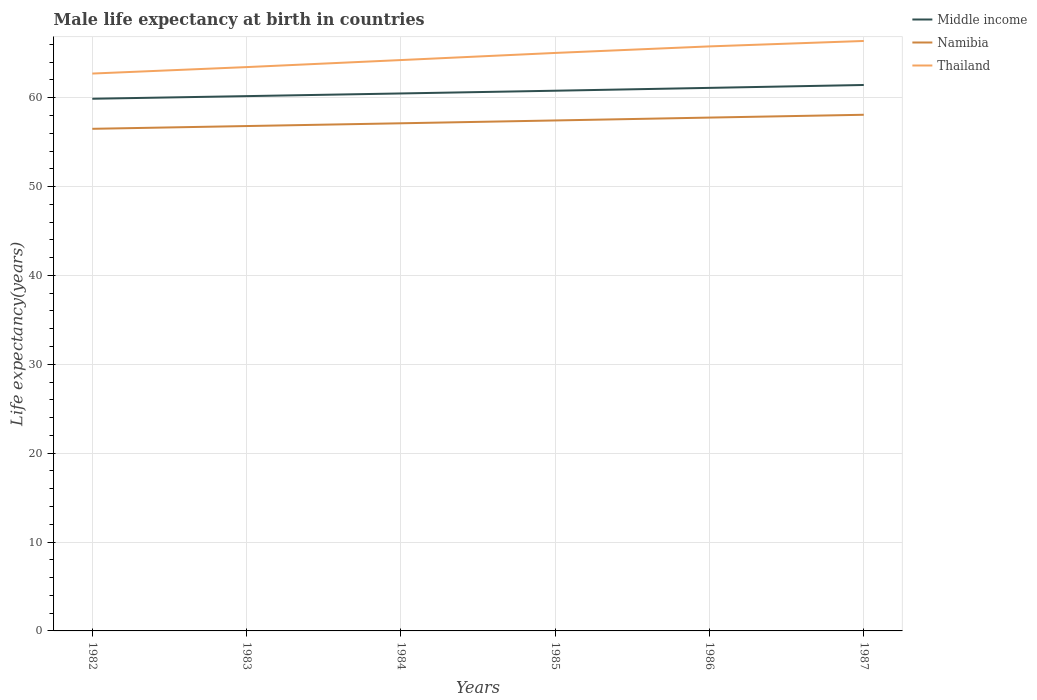Does the line corresponding to Namibia intersect with the line corresponding to Middle income?
Your answer should be compact. No. Across all years, what is the maximum male life expectancy at birth in Namibia?
Provide a succinct answer. 56.5. In which year was the male life expectancy at birth in Thailand maximum?
Offer a terse response. 1982. What is the total male life expectancy at birth in Namibia in the graph?
Offer a terse response. -0.94. What is the difference between the highest and the second highest male life expectancy at birth in Middle income?
Your response must be concise. 1.55. What is the difference between the highest and the lowest male life expectancy at birth in Middle income?
Ensure brevity in your answer.  3. Is the male life expectancy at birth in Middle income strictly greater than the male life expectancy at birth in Namibia over the years?
Provide a short and direct response. No. What is the difference between two consecutive major ticks on the Y-axis?
Ensure brevity in your answer.  10. Are the values on the major ticks of Y-axis written in scientific E-notation?
Provide a short and direct response. No. Does the graph contain grids?
Provide a succinct answer. Yes. Where does the legend appear in the graph?
Offer a very short reply. Top right. What is the title of the graph?
Your answer should be very brief. Male life expectancy at birth in countries. What is the label or title of the X-axis?
Offer a very short reply. Years. What is the label or title of the Y-axis?
Your answer should be compact. Life expectancy(years). What is the Life expectancy(years) of Middle income in 1982?
Make the answer very short. 59.88. What is the Life expectancy(years) in Namibia in 1982?
Your answer should be very brief. 56.5. What is the Life expectancy(years) in Thailand in 1982?
Your response must be concise. 62.72. What is the Life expectancy(years) in Middle income in 1983?
Offer a terse response. 60.18. What is the Life expectancy(years) of Namibia in 1983?
Keep it short and to the point. 56.81. What is the Life expectancy(years) of Thailand in 1983?
Offer a very short reply. 63.45. What is the Life expectancy(years) of Middle income in 1984?
Offer a terse response. 60.48. What is the Life expectancy(years) of Namibia in 1984?
Keep it short and to the point. 57.12. What is the Life expectancy(years) of Thailand in 1984?
Offer a terse response. 64.24. What is the Life expectancy(years) of Middle income in 1985?
Your answer should be very brief. 60.79. What is the Life expectancy(years) in Namibia in 1985?
Give a very brief answer. 57.44. What is the Life expectancy(years) in Thailand in 1985?
Offer a very short reply. 65.04. What is the Life expectancy(years) in Middle income in 1986?
Ensure brevity in your answer.  61.11. What is the Life expectancy(years) in Namibia in 1986?
Your answer should be very brief. 57.77. What is the Life expectancy(years) in Thailand in 1986?
Your answer should be very brief. 65.78. What is the Life expectancy(years) in Middle income in 1987?
Provide a succinct answer. 61.43. What is the Life expectancy(years) of Namibia in 1987?
Provide a short and direct response. 58.08. What is the Life expectancy(years) in Thailand in 1987?
Keep it short and to the point. 66.39. Across all years, what is the maximum Life expectancy(years) of Middle income?
Keep it short and to the point. 61.43. Across all years, what is the maximum Life expectancy(years) of Namibia?
Provide a short and direct response. 58.08. Across all years, what is the maximum Life expectancy(years) of Thailand?
Ensure brevity in your answer.  66.39. Across all years, what is the minimum Life expectancy(years) in Middle income?
Give a very brief answer. 59.88. Across all years, what is the minimum Life expectancy(years) of Namibia?
Keep it short and to the point. 56.5. Across all years, what is the minimum Life expectancy(years) in Thailand?
Your answer should be compact. 62.72. What is the total Life expectancy(years) of Middle income in the graph?
Offer a very short reply. 363.87. What is the total Life expectancy(years) of Namibia in the graph?
Your response must be concise. 343.73. What is the total Life expectancy(years) of Thailand in the graph?
Provide a succinct answer. 387.6. What is the difference between the Life expectancy(years) of Middle income in 1982 and that in 1983?
Your answer should be compact. -0.3. What is the difference between the Life expectancy(years) of Namibia in 1982 and that in 1983?
Ensure brevity in your answer.  -0.31. What is the difference between the Life expectancy(years) of Thailand in 1982 and that in 1983?
Make the answer very short. -0.73. What is the difference between the Life expectancy(years) of Middle income in 1982 and that in 1984?
Offer a very short reply. -0.6. What is the difference between the Life expectancy(years) in Namibia in 1982 and that in 1984?
Your response must be concise. -0.62. What is the difference between the Life expectancy(years) of Thailand in 1982 and that in 1984?
Provide a succinct answer. -1.52. What is the difference between the Life expectancy(years) of Middle income in 1982 and that in 1985?
Provide a succinct answer. -0.9. What is the difference between the Life expectancy(years) in Namibia in 1982 and that in 1985?
Offer a very short reply. -0.94. What is the difference between the Life expectancy(years) of Thailand in 1982 and that in 1985?
Offer a terse response. -2.32. What is the difference between the Life expectancy(years) of Middle income in 1982 and that in 1986?
Keep it short and to the point. -1.22. What is the difference between the Life expectancy(years) of Namibia in 1982 and that in 1986?
Keep it short and to the point. -1.26. What is the difference between the Life expectancy(years) in Thailand in 1982 and that in 1986?
Keep it short and to the point. -3.06. What is the difference between the Life expectancy(years) in Middle income in 1982 and that in 1987?
Your answer should be very brief. -1.55. What is the difference between the Life expectancy(years) in Namibia in 1982 and that in 1987?
Keep it short and to the point. -1.58. What is the difference between the Life expectancy(years) in Thailand in 1982 and that in 1987?
Your answer should be compact. -3.67. What is the difference between the Life expectancy(years) of Middle income in 1983 and that in 1984?
Ensure brevity in your answer.  -0.3. What is the difference between the Life expectancy(years) in Namibia in 1983 and that in 1984?
Your answer should be very brief. -0.31. What is the difference between the Life expectancy(years) in Thailand in 1983 and that in 1984?
Your answer should be very brief. -0.79. What is the difference between the Life expectancy(years) in Middle income in 1983 and that in 1985?
Your answer should be very brief. -0.61. What is the difference between the Life expectancy(years) of Namibia in 1983 and that in 1985?
Ensure brevity in your answer.  -0.63. What is the difference between the Life expectancy(years) of Thailand in 1983 and that in 1985?
Keep it short and to the point. -1.59. What is the difference between the Life expectancy(years) of Middle income in 1983 and that in 1986?
Provide a short and direct response. -0.93. What is the difference between the Life expectancy(years) of Namibia in 1983 and that in 1986?
Your answer should be very brief. -0.95. What is the difference between the Life expectancy(years) in Thailand in 1983 and that in 1986?
Offer a terse response. -2.33. What is the difference between the Life expectancy(years) in Middle income in 1983 and that in 1987?
Provide a short and direct response. -1.25. What is the difference between the Life expectancy(years) of Namibia in 1983 and that in 1987?
Provide a succinct answer. -1.27. What is the difference between the Life expectancy(years) of Thailand in 1983 and that in 1987?
Your answer should be compact. -2.94. What is the difference between the Life expectancy(years) in Middle income in 1984 and that in 1985?
Your answer should be compact. -0.31. What is the difference between the Life expectancy(years) in Namibia in 1984 and that in 1985?
Your response must be concise. -0.32. What is the difference between the Life expectancy(years) of Thailand in 1984 and that in 1985?
Provide a succinct answer. -0.8. What is the difference between the Life expectancy(years) of Middle income in 1984 and that in 1986?
Provide a succinct answer. -0.63. What is the difference between the Life expectancy(years) in Namibia in 1984 and that in 1986?
Give a very brief answer. -0.64. What is the difference between the Life expectancy(years) of Thailand in 1984 and that in 1986?
Offer a very short reply. -1.54. What is the difference between the Life expectancy(years) in Middle income in 1984 and that in 1987?
Make the answer very short. -0.95. What is the difference between the Life expectancy(years) of Namibia in 1984 and that in 1987?
Your answer should be compact. -0.96. What is the difference between the Life expectancy(years) of Thailand in 1984 and that in 1987?
Your answer should be compact. -2.15. What is the difference between the Life expectancy(years) of Middle income in 1985 and that in 1986?
Offer a terse response. -0.32. What is the difference between the Life expectancy(years) of Namibia in 1985 and that in 1986?
Ensure brevity in your answer.  -0.32. What is the difference between the Life expectancy(years) in Thailand in 1985 and that in 1986?
Ensure brevity in your answer.  -0.74. What is the difference between the Life expectancy(years) in Middle income in 1985 and that in 1987?
Keep it short and to the point. -0.64. What is the difference between the Life expectancy(years) in Namibia in 1985 and that in 1987?
Ensure brevity in your answer.  -0.64. What is the difference between the Life expectancy(years) in Thailand in 1985 and that in 1987?
Offer a terse response. -1.35. What is the difference between the Life expectancy(years) in Middle income in 1986 and that in 1987?
Offer a terse response. -0.33. What is the difference between the Life expectancy(years) of Namibia in 1986 and that in 1987?
Your answer should be very brief. -0.32. What is the difference between the Life expectancy(years) in Thailand in 1986 and that in 1987?
Offer a terse response. -0.61. What is the difference between the Life expectancy(years) of Middle income in 1982 and the Life expectancy(years) of Namibia in 1983?
Offer a terse response. 3.07. What is the difference between the Life expectancy(years) in Middle income in 1982 and the Life expectancy(years) in Thailand in 1983?
Offer a very short reply. -3.56. What is the difference between the Life expectancy(years) in Namibia in 1982 and the Life expectancy(years) in Thailand in 1983?
Your response must be concise. -6.95. What is the difference between the Life expectancy(years) of Middle income in 1982 and the Life expectancy(years) of Namibia in 1984?
Provide a succinct answer. 2.76. What is the difference between the Life expectancy(years) in Middle income in 1982 and the Life expectancy(years) in Thailand in 1984?
Provide a succinct answer. -4.35. What is the difference between the Life expectancy(years) in Namibia in 1982 and the Life expectancy(years) in Thailand in 1984?
Provide a short and direct response. -7.74. What is the difference between the Life expectancy(years) in Middle income in 1982 and the Life expectancy(years) in Namibia in 1985?
Give a very brief answer. 2.44. What is the difference between the Life expectancy(years) in Middle income in 1982 and the Life expectancy(years) in Thailand in 1985?
Give a very brief answer. -5.15. What is the difference between the Life expectancy(years) in Namibia in 1982 and the Life expectancy(years) in Thailand in 1985?
Keep it short and to the point. -8.54. What is the difference between the Life expectancy(years) in Middle income in 1982 and the Life expectancy(years) in Namibia in 1986?
Offer a very short reply. 2.12. What is the difference between the Life expectancy(years) in Middle income in 1982 and the Life expectancy(years) in Thailand in 1986?
Keep it short and to the point. -5.89. What is the difference between the Life expectancy(years) of Namibia in 1982 and the Life expectancy(years) of Thailand in 1986?
Keep it short and to the point. -9.28. What is the difference between the Life expectancy(years) in Middle income in 1982 and the Life expectancy(years) in Namibia in 1987?
Give a very brief answer. 1.8. What is the difference between the Life expectancy(years) of Middle income in 1982 and the Life expectancy(years) of Thailand in 1987?
Provide a succinct answer. -6.5. What is the difference between the Life expectancy(years) in Namibia in 1982 and the Life expectancy(years) in Thailand in 1987?
Your answer should be compact. -9.88. What is the difference between the Life expectancy(years) of Middle income in 1983 and the Life expectancy(years) of Namibia in 1984?
Offer a very short reply. 3.06. What is the difference between the Life expectancy(years) of Middle income in 1983 and the Life expectancy(years) of Thailand in 1984?
Give a very brief answer. -4.06. What is the difference between the Life expectancy(years) of Namibia in 1983 and the Life expectancy(years) of Thailand in 1984?
Your answer should be very brief. -7.43. What is the difference between the Life expectancy(years) in Middle income in 1983 and the Life expectancy(years) in Namibia in 1985?
Your answer should be compact. 2.74. What is the difference between the Life expectancy(years) in Middle income in 1983 and the Life expectancy(years) in Thailand in 1985?
Your answer should be compact. -4.86. What is the difference between the Life expectancy(years) of Namibia in 1983 and the Life expectancy(years) of Thailand in 1985?
Provide a short and direct response. -8.23. What is the difference between the Life expectancy(years) in Middle income in 1983 and the Life expectancy(years) in Namibia in 1986?
Offer a terse response. 2.42. What is the difference between the Life expectancy(years) of Middle income in 1983 and the Life expectancy(years) of Thailand in 1986?
Give a very brief answer. -5.6. What is the difference between the Life expectancy(years) in Namibia in 1983 and the Life expectancy(years) in Thailand in 1986?
Give a very brief answer. -8.96. What is the difference between the Life expectancy(years) of Middle income in 1983 and the Life expectancy(years) of Namibia in 1987?
Provide a succinct answer. 2.1. What is the difference between the Life expectancy(years) in Middle income in 1983 and the Life expectancy(years) in Thailand in 1987?
Your answer should be very brief. -6.21. What is the difference between the Life expectancy(years) in Namibia in 1983 and the Life expectancy(years) in Thailand in 1987?
Provide a short and direct response. -9.57. What is the difference between the Life expectancy(years) in Middle income in 1984 and the Life expectancy(years) in Namibia in 1985?
Provide a succinct answer. 3.04. What is the difference between the Life expectancy(years) of Middle income in 1984 and the Life expectancy(years) of Thailand in 1985?
Provide a short and direct response. -4.56. What is the difference between the Life expectancy(years) in Namibia in 1984 and the Life expectancy(years) in Thailand in 1985?
Ensure brevity in your answer.  -7.92. What is the difference between the Life expectancy(years) in Middle income in 1984 and the Life expectancy(years) in Namibia in 1986?
Offer a terse response. 2.71. What is the difference between the Life expectancy(years) in Middle income in 1984 and the Life expectancy(years) in Thailand in 1986?
Provide a succinct answer. -5.3. What is the difference between the Life expectancy(years) of Namibia in 1984 and the Life expectancy(years) of Thailand in 1986?
Make the answer very short. -8.65. What is the difference between the Life expectancy(years) in Middle income in 1984 and the Life expectancy(years) in Namibia in 1987?
Your response must be concise. 2.4. What is the difference between the Life expectancy(years) in Middle income in 1984 and the Life expectancy(years) in Thailand in 1987?
Your answer should be compact. -5.91. What is the difference between the Life expectancy(years) in Namibia in 1984 and the Life expectancy(years) in Thailand in 1987?
Ensure brevity in your answer.  -9.26. What is the difference between the Life expectancy(years) of Middle income in 1985 and the Life expectancy(years) of Namibia in 1986?
Provide a succinct answer. 3.02. What is the difference between the Life expectancy(years) of Middle income in 1985 and the Life expectancy(years) of Thailand in 1986?
Offer a terse response. -4.99. What is the difference between the Life expectancy(years) of Namibia in 1985 and the Life expectancy(years) of Thailand in 1986?
Offer a very short reply. -8.34. What is the difference between the Life expectancy(years) of Middle income in 1985 and the Life expectancy(years) of Namibia in 1987?
Your answer should be very brief. 2.71. What is the difference between the Life expectancy(years) of Middle income in 1985 and the Life expectancy(years) of Thailand in 1987?
Keep it short and to the point. -5.6. What is the difference between the Life expectancy(years) in Namibia in 1985 and the Life expectancy(years) in Thailand in 1987?
Your response must be concise. -8.95. What is the difference between the Life expectancy(years) in Middle income in 1986 and the Life expectancy(years) in Namibia in 1987?
Your response must be concise. 3.03. What is the difference between the Life expectancy(years) of Middle income in 1986 and the Life expectancy(years) of Thailand in 1987?
Make the answer very short. -5.28. What is the difference between the Life expectancy(years) in Namibia in 1986 and the Life expectancy(years) in Thailand in 1987?
Your answer should be compact. -8.62. What is the average Life expectancy(years) of Middle income per year?
Provide a short and direct response. 60.65. What is the average Life expectancy(years) in Namibia per year?
Give a very brief answer. 57.29. What is the average Life expectancy(years) of Thailand per year?
Offer a terse response. 64.6. In the year 1982, what is the difference between the Life expectancy(years) in Middle income and Life expectancy(years) in Namibia?
Provide a succinct answer. 3.38. In the year 1982, what is the difference between the Life expectancy(years) of Middle income and Life expectancy(years) of Thailand?
Your answer should be compact. -2.83. In the year 1982, what is the difference between the Life expectancy(years) of Namibia and Life expectancy(years) of Thailand?
Provide a short and direct response. -6.22. In the year 1983, what is the difference between the Life expectancy(years) in Middle income and Life expectancy(years) in Namibia?
Give a very brief answer. 3.37. In the year 1983, what is the difference between the Life expectancy(years) of Middle income and Life expectancy(years) of Thailand?
Keep it short and to the point. -3.27. In the year 1983, what is the difference between the Life expectancy(years) in Namibia and Life expectancy(years) in Thailand?
Your answer should be very brief. -6.63. In the year 1984, what is the difference between the Life expectancy(years) in Middle income and Life expectancy(years) in Namibia?
Ensure brevity in your answer.  3.36. In the year 1984, what is the difference between the Life expectancy(years) in Middle income and Life expectancy(years) in Thailand?
Your answer should be compact. -3.76. In the year 1984, what is the difference between the Life expectancy(years) of Namibia and Life expectancy(years) of Thailand?
Your answer should be very brief. -7.11. In the year 1985, what is the difference between the Life expectancy(years) of Middle income and Life expectancy(years) of Namibia?
Your answer should be very brief. 3.35. In the year 1985, what is the difference between the Life expectancy(years) of Middle income and Life expectancy(years) of Thailand?
Give a very brief answer. -4.25. In the year 1985, what is the difference between the Life expectancy(years) of Namibia and Life expectancy(years) of Thailand?
Make the answer very short. -7.6. In the year 1986, what is the difference between the Life expectancy(years) of Middle income and Life expectancy(years) of Namibia?
Keep it short and to the point. 3.34. In the year 1986, what is the difference between the Life expectancy(years) of Middle income and Life expectancy(years) of Thailand?
Your response must be concise. -4.67. In the year 1986, what is the difference between the Life expectancy(years) of Namibia and Life expectancy(years) of Thailand?
Keep it short and to the point. -8.01. In the year 1987, what is the difference between the Life expectancy(years) of Middle income and Life expectancy(years) of Namibia?
Your answer should be very brief. 3.35. In the year 1987, what is the difference between the Life expectancy(years) of Middle income and Life expectancy(years) of Thailand?
Make the answer very short. -4.95. In the year 1987, what is the difference between the Life expectancy(years) of Namibia and Life expectancy(years) of Thailand?
Ensure brevity in your answer.  -8.3. What is the ratio of the Life expectancy(years) of Namibia in 1982 to that in 1983?
Ensure brevity in your answer.  0.99. What is the ratio of the Life expectancy(years) in Thailand in 1982 to that in 1983?
Your answer should be compact. 0.99. What is the ratio of the Life expectancy(years) in Middle income in 1982 to that in 1984?
Your answer should be very brief. 0.99. What is the ratio of the Life expectancy(years) of Thailand in 1982 to that in 1984?
Your answer should be very brief. 0.98. What is the ratio of the Life expectancy(years) of Middle income in 1982 to that in 1985?
Ensure brevity in your answer.  0.99. What is the ratio of the Life expectancy(years) in Namibia in 1982 to that in 1985?
Your answer should be very brief. 0.98. What is the ratio of the Life expectancy(years) of Middle income in 1982 to that in 1986?
Your answer should be compact. 0.98. What is the ratio of the Life expectancy(years) in Namibia in 1982 to that in 1986?
Your answer should be very brief. 0.98. What is the ratio of the Life expectancy(years) of Thailand in 1982 to that in 1986?
Ensure brevity in your answer.  0.95. What is the ratio of the Life expectancy(years) in Middle income in 1982 to that in 1987?
Provide a short and direct response. 0.97. What is the ratio of the Life expectancy(years) of Namibia in 1982 to that in 1987?
Ensure brevity in your answer.  0.97. What is the ratio of the Life expectancy(years) in Thailand in 1982 to that in 1987?
Ensure brevity in your answer.  0.94. What is the ratio of the Life expectancy(years) of Middle income in 1983 to that in 1985?
Provide a succinct answer. 0.99. What is the ratio of the Life expectancy(years) of Namibia in 1983 to that in 1985?
Make the answer very short. 0.99. What is the ratio of the Life expectancy(years) in Thailand in 1983 to that in 1985?
Your response must be concise. 0.98. What is the ratio of the Life expectancy(years) in Namibia in 1983 to that in 1986?
Keep it short and to the point. 0.98. What is the ratio of the Life expectancy(years) in Thailand in 1983 to that in 1986?
Offer a terse response. 0.96. What is the ratio of the Life expectancy(years) in Middle income in 1983 to that in 1987?
Your response must be concise. 0.98. What is the ratio of the Life expectancy(years) in Namibia in 1983 to that in 1987?
Your response must be concise. 0.98. What is the ratio of the Life expectancy(years) in Thailand in 1983 to that in 1987?
Offer a very short reply. 0.96. What is the ratio of the Life expectancy(years) of Middle income in 1984 to that in 1985?
Your answer should be compact. 0.99. What is the ratio of the Life expectancy(years) in Middle income in 1984 to that in 1986?
Provide a short and direct response. 0.99. What is the ratio of the Life expectancy(years) of Namibia in 1984 to that in 1986?
Give a very brief answer. 0.99. What is the ratio of the Life expectancy(years) in Thailand in 1984 to that in 1986?
Keep it short and to the point. 0.98. What is the ratio of the Life expectancy(years) of Middle income in 1984 to that in 1987?
Offer a very short reply. 0.98. What is the ratio of the Life expectancy(years) of Namibia in 1984 to that in 1987?
Your answer should be very brief. 0.98. What is the ratio of the Life expectancy(years) in Thailand in 1984 to that in 1987?
Provide a short and direct response. 0.97. What is the ratio of the Life expectancy(years) of Namibia in 1985 to that in 1986?
Ensure brevity in your answer.  0.99. What is the ratio of the Life expectancy(years) of Middle income in 1985 to that in 1987?
Keep it short and to the point. 0.99. What is the ratio of the Life expectancy(years) in Thailand in 1985 to that in 1987?
Your answer should be very brief. 0.98. What is the ratio of the Life expectancy(years) of Thailand in 1986 to that in 1987?
Ensure brevity in your answer.  0.99. What is the difference between the highest and the second highest Life expectancy(years) in Middle income?
Make the answer very short. 0.33. What is the difference between the highest and the second highest Life expectancy(years) in Namibia?
Your answer should be very brief. 0.32. What is the difference between the highest and the second highest Life expectancy(years) in Thailand?
Offer a terse response. 0.61. What is the difference between the highest and the lowest Life expectancy(years) of Middle income?
Offer a very short reply. 1.55. What is the difference between the highest and the lowest Life expectancy(years) in Namibia?
Your answer should be compact. 1.58. What is the difference between the highest and the lowest Life expectancy(years) of Thailand?
Keep it short and to the point. 3.67. 